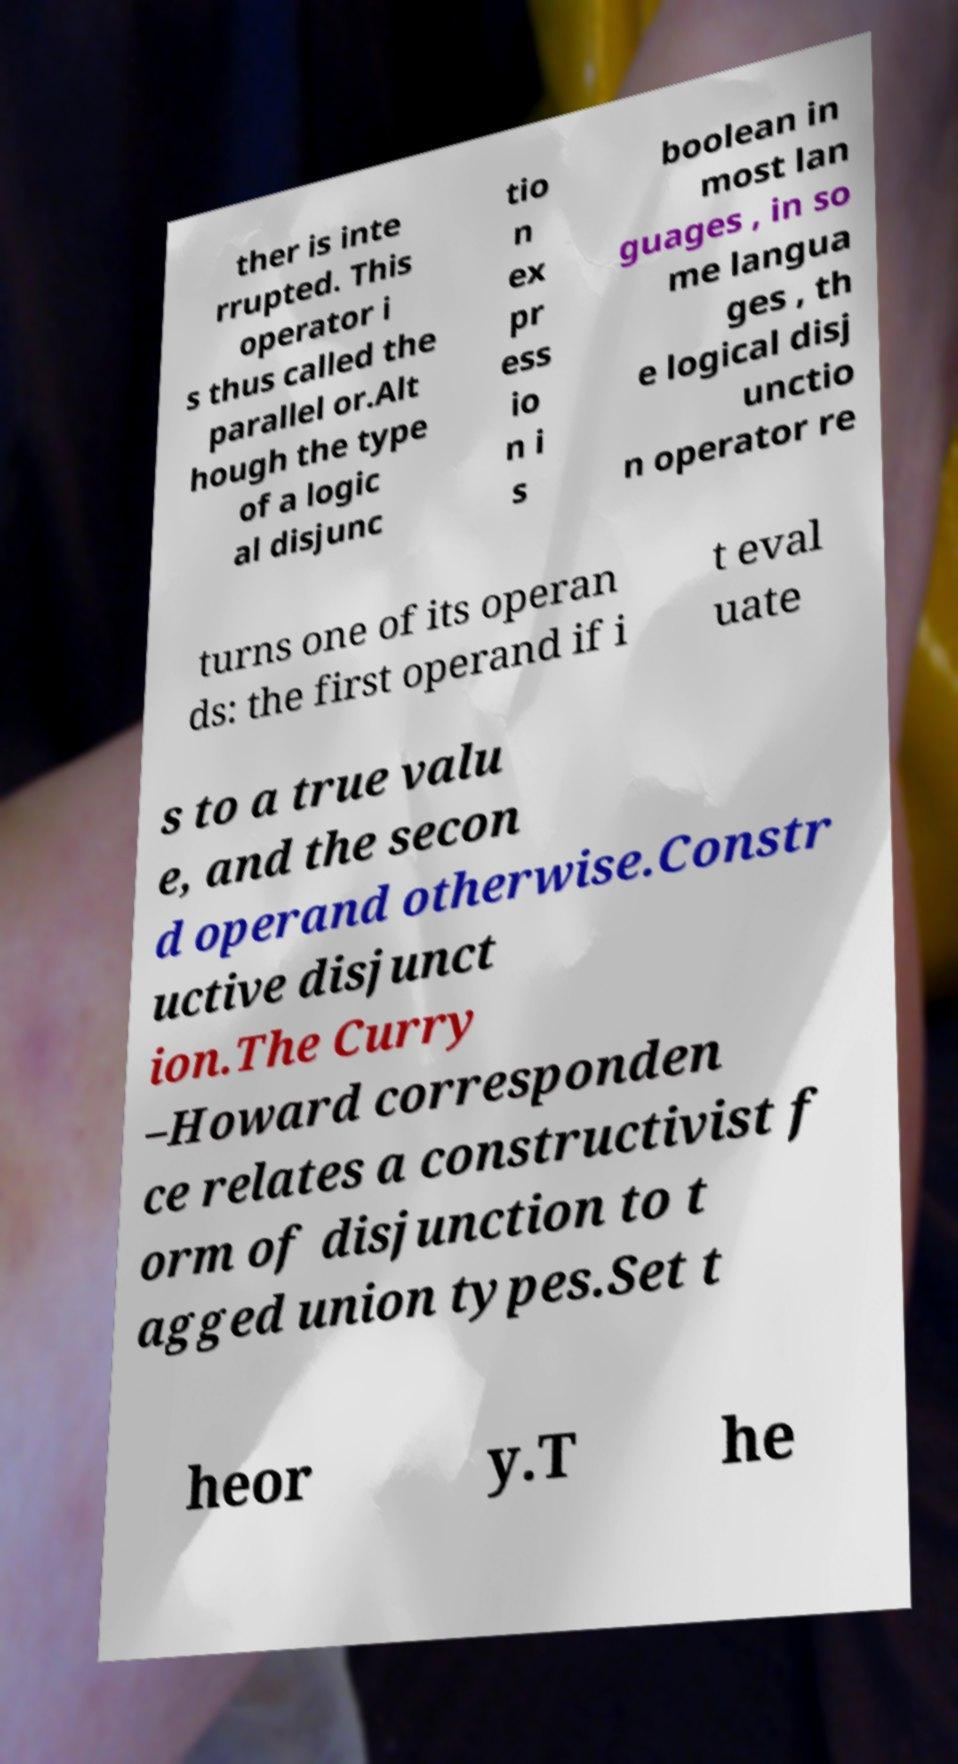Can you accurately transcribe the text from the provided image for me? ther is inte rrupted. This operator i s thus called the parallel or.Alt hough the type of a logic al disjunc tio n ex pr ess io n i s boolean in most lan guages , in so me langua ges , th e logical disj unctio n operator re turns one of its operan ds: the first operand if i t eval uate s to a true valu e, and the secon d operand otherwise.Constr uctive disjunct ion.The Curry –Howard corresponden ce relates a constructivist f orm of disjunction to t agged union types.Set t heor y.T he 